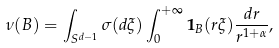<formula> <loc_0><loc_0><loc_500><loc_500>\nu ( B ) = \int _ { S ^ { d - 1 } } \sigma ( d \xi ) \int _ { 0 } ^ { + \infty } \mathbf 1 _ { B } ( r \xi ) \frac { d r } { r ^ { 1 + \alpha } } ,</formula> 